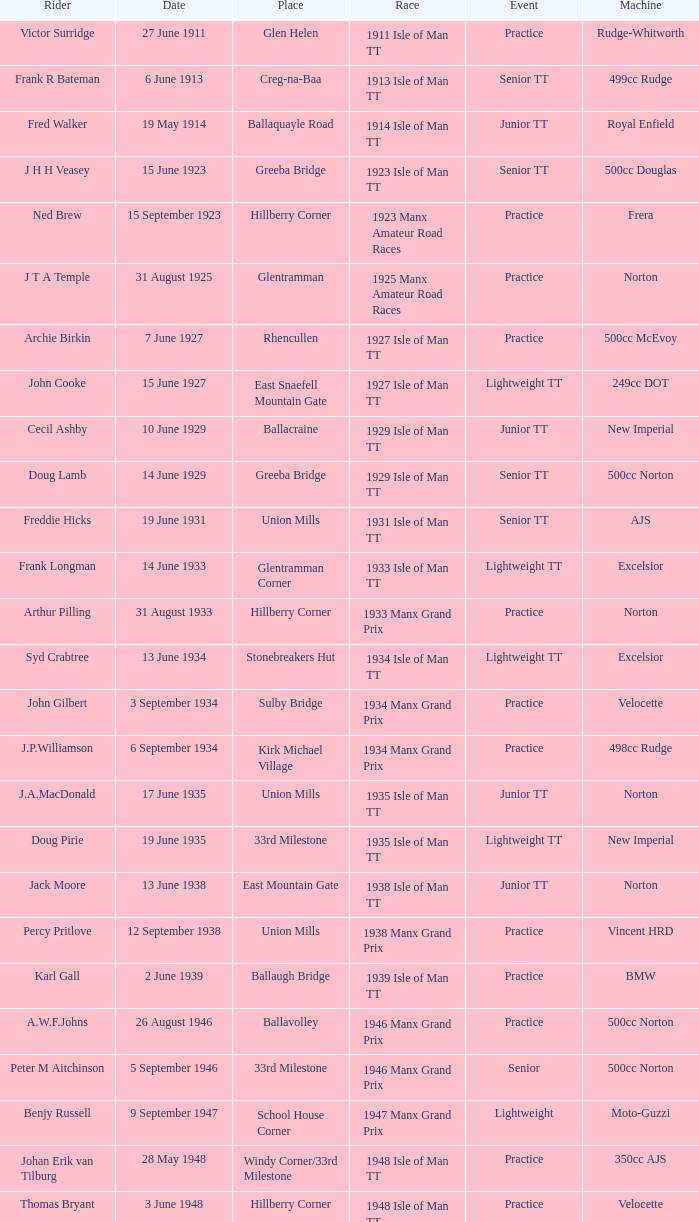What event was Rob Vine riding? Senior TT. 